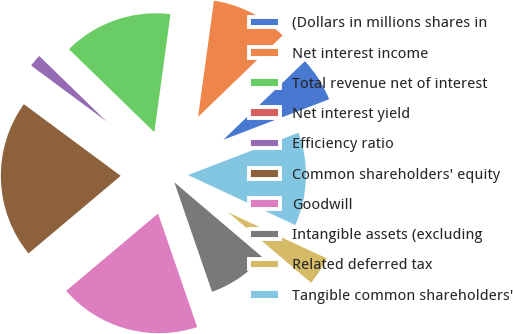Convert chart. <chart><loc_0><loc_0><loc_500><loc_500><pie_chart><fcel>(Dollars in millions shares in<fcel>Net interest income<fcel>Total revenue net of interest<fcel>Net interest yield<fcel>Efficiency ratio<fcel>Common shareholders' equity<fcel>Goodwill<fcel>Intangible assets (excluding<fcel>Related deferred tax<fcel>Tangible common shareholders'<nl><fcel>6.38%<fcel>10.64%<fcel>14.89%<fcel>0.0%<fcel>2.13%<fcel>21.28%<fcel>19.15%<fcel>8.51%<fcel>4.26%<fcel>12.77%<nl></chart> 